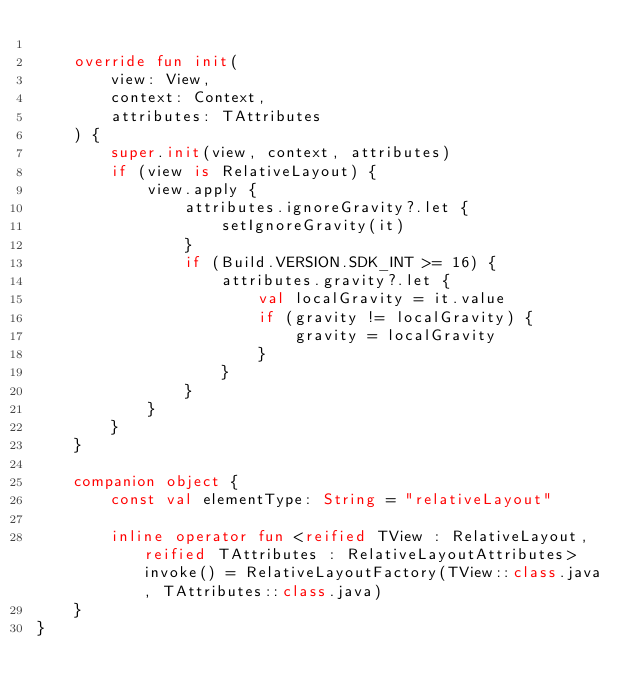Convert code to text. <code><loc_0><loc_0><loc_500><loc_500><_Kotlin_>
    override fun init(
        view: View,
        context: Context,
        attributes: TAttributes
    ) {
        super.init(view, context, attributes)
        if (view is RelativeLayout) {
            view.apply {
                attributes.ignoreGravity?.let {
                    setIgnoreGravity(it)
                }
                if (Build.VERSION.SDK_INT >= 16) {
                    attributes.gravity?.let {
                        val localGravity = it.value
                        if (gravity != localGravity) {
                            gravity = localGravity
                        }
                    }
                }
            }
        }
    }

    companion object {
        const val elementType: String = "relativeLayout"

        inline operator fun <reified TView : RelativeLayout, reified TAttributes : RelativeLayoutAttributes> invoke() = RelativeLayoutFactory(TView::class.java, TAttributes::class.java)
    }
}
</code> 